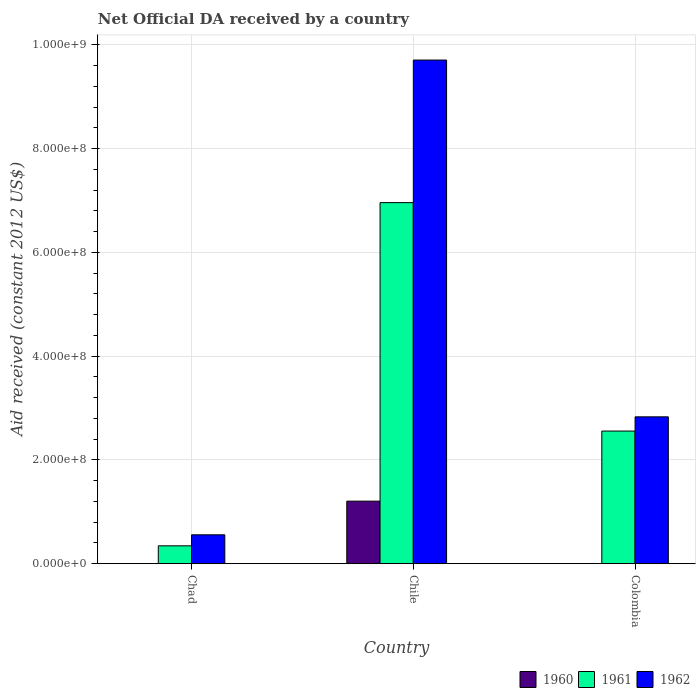How many different coloured bars are there?
Ensure brevity in your answer.  3. How many groups of bars are there?
Offer a terse response. 3. How many bars are there on the 3rd tick from the left?
Your answer should be compact. 2. Across all countries, what is the maximum net official development assistance aid received in 1962?
Make the answer very short. 9.71e+08. Across all countries, what is the minimum net official development assistance aid received in 1961?
Provide a succinct answer. 3.45e+07. In which country was the net official development assistance aid received in 1960 maximum?
Offer a very short reply. Chile. What is the total net official development assistance aid received in 1961 in the graph?
Your answer should be compact. 9.86e+08. What is the difference between the net official development assistance aid received in 1960 in Chad and that in Chile?
Offer a terse response. -1.20e+08. What is the difference between the net official development assistance aid received in 1962 in Chile and the net official development assistance aid received in 1960 in Colombia?
Offer a very short reply. 9.71e+08. What is the average net official development assistance aid received in 1961 per country?
Make the answer very short. 3.29e+08. What is the difference between the net official development assistance aid received of/in 1961 and net official development assistance aid received of/in 1962 in Chile?
Offer a very short reply. -2.75e+08. In how many countries, is the net official development assistance aid received in 1962 greater than 440000000 US$?
Make the answer very short. 1. What is the ratio of the net official development assistance aid received in 1962 in Chile to that in Colombia?
Provide a succinct answer. 3.43. Is the net official development assistance aid received in 1962 in Chad less than that in Chile?
Give a very brief answer. Yes. What is the difference between the highest and the second highest net official development assistance aid received in 1961?
Offer a terse response. 4.40e+08. What is the difference between the highest and the lowest net official development assistance aid received in 1961?
Your response must be concise. 6.61e+08. How many countries are there in the graph?
Offer a terse response. 3. What is the difference between two consecutive major ticks on the Y-axis?
Ensure brevity in your answer.  2.00e+08. Does the graph contain any zero values?
Your answer should be compact. Yes. Where does the legend appear in the graph?
Your response must be concise. Bottom right. How many legend labels are there?
Your answer should be compact. 3. How are the legend labels stacked?
Your answer should be compact. Horizontal. What is the title of the graph?
Offer a very short reply. Net Official DA received by a country. What is the label or title of the X-axis?
Your answer should be very brief. Country. What is the label or title of the Y-axis?
Offer a very short reply. Aid received (constant 2012 US$). What is the Aid received (constant 2012 US$) of 1960 in Chad?
Keep it short and to the point. 3.00e+05. What is the Aid received (constant 2012 US$) of 1961 in Chad?
Your answer should be compact. 3.45e+07. What is the Aid received (constant 2012 US$) in 1962 in Chad?
Give a very brief answer. 5.57e+07. What is the Aid received (constant 2012 US$) in 1960 in Chile?
Keep it short and to the point. 1.21e+08. What is the Aid received (constant 2012 US$) in 1961 in Chile?
Make the answer very short. 6.96e+08. What is the Aid received (constant 2012 US$) in 1962 in Chile?
Make the answer very short. 9.71e+08. What is the Aid received (constant 2012 US$) in 1960 in Colombia?
Your response must be concise. 0. What is the Aid received (constant 2012 US$) of 1961 in Colombia?
Provide a succinct answer. 2.56e+08. What is the Aid received (constant 2012 US$) of 1962 in Colombia?
Your response must be concise. 2.83e+08. Across all countries, what is the maximum Aid received (constant 2012 US$) of 1960?
Provide a short and direct response. 1.21e+08. Across all countries, what is the maximum Aid received (constant 2012 US$) in 1961?
Your answer should be compact. 6.96e+08. Across all countries, what is the maximum Aid received (constant 2012 US$) of 1962?
Ensure brevity in your answer.  9.71e+08. Across all countries, what is the minimum Aid received (constant 2012 US$) in 1960?
Offer a terse response. 0. Across all countries, what is the minimum Aid received (constant 2012 US$) in 1961?
Your answer should be compact. 3.45e+07. Across all countries, what is the minimum Aid received (constant 2012 US$) in 1962?
Make the answer very short. 5.57e+07. What is the total Aid received (constant 2012 US$) of 1960 in the graph?
Give a very brief answer. 1.21e+08. What is the total Aid received (constant 2012 US$) of 1961 in the graph?
Make the answer very short. 9.86e+08. What is the total Aid received (constant 2012 US$) of 1962 in the graph?
Your answer should be compact. 1.31e+09. What is the difference between the Aid received (constant 2012 US$) of 1960 in Chad and that in Chile?
Provide a succinct answer. -1.20e+08. What is the difference between the Aid received (constant 2012 US$) in 1961 in Chad and that in Chile?
Make the answer very short. -6.61e+08. What is the difference between the Aid received (constant 2012 US$) in 1962 in Chad and that in Chile?
Give a very brief answer. -9.15e+08. What is the difference between the Aid received (constant 2012 US$) of 1961 in Chad and that in Colombia?
Ensure brevity in your answer.  -2.21e+08. What is the difference between the Aid received (constant 2012 US$) in 1962 in Chad and that in Colombia?
Your response must be concise. -2.27e+08. What is the difference between the Aid received (constant 2012 US$) of 1961 in Chile and that in Colombia?
Your response must be concise. 4.40e+08. What is the difference between the Aid received (constant 2012 US$) of 1962 in Chile and that in Colombia?
Provide a succinct answer. 6.88e+08. What is the difference between the Aid received (constant 2012 US$) in 1960 in Chad and the Aid received (constant 2012 US$) in 1961 in Chile?
Provide a succinct answer. -6.96e+08. What is the difference between the Aid received (constant 2012 US$) in 1960 in Chad and the Aid received (constant 2012 US$) in 1962 in Chile?
Give a very brief answer. -9.70e+08. What is the difference between the Aid received (constant 2012 US$) in 1961 in Chad and the Aid received (constant 2012 US$) in 1962 in Chile?
Offer a very short reply. -9.36e+08. What is the difference between the Aid received (constant 2012 US$) of 1960 in Chad and the Aid received (constant 2012 US$) of 1961 in Colombia?
Ensure brevity in your answer.  -2.55e+08. What is the difference between the Aid received (constant 2012 US$) in 1960 in Chad and the Aid received (constant 2012 US$) in 1962 in Colombia?
Your answer should be very brief. -2.83e+08. What is the difference between the Aid received (constant 2012 US$) in 1961 in Chad and the Aid received (constant 2012 US$) in 1962 in Colombia?
Your answer should be compact. -2.49e+08. What is the difference between the Aid received (constant 2012 US$) in 1960 in Chile and the Aid received (constant 2012 US$) in 1961 in Colombia?
Your answer should be compact. -1.35e+08. What is the difference between the Aid received (constant 2012 US$) in 1960 in Chile and the Aid received (constant 2012 US$) in 1962 in Colombia?
Ensure brevity in your answer.  -1.63e+08. What is the difference between the Aid received (constant 2012 US$) in 1961 in Chile and the Aid received (constant 2012 US$) in 1962 in Colombia?
Provide a short and direct response. 4.13e+08. What is the average Aid received (constant 2012 US$) of 1960 per country?
Make the answer very short. 4.03e+07. What is the average Aid received (constant 2012 US$) of 1961 per country?
Offer a very short reply. 3.29e+08. What is the average Aid received (constant 2012 US$) in 1962 per country?
Offer a very short reply. 4.37e+08. What is the difference between the Aid received (constant 2012 US$) of 1960 and Aid received (constant 2012 US$) of 1961 in Chad?
Offer a terse response. -3.42e+07. What is the difference between the Aid received (constant 2012 US$) in 1960 and Aid received (constant 2012 US$) in 1962 in Chad?
Give a very brief answer. -5.54e+07. What is the difference between the Aid received (constant 2012 US$) in 1961 and Aid received (constant 2012 US$) in 1962 in Chad?
Make the answer very short. -2.12e+07. What is the difference between the Aid received (constant 2012 US$) of 1960 and Aid received (constant 2012 US$) of 1961 in Chile?
Give a very brief answer. -5.75e+08. What is the difference between the Aid received (constant 2012 US$) in 1960 and Aid received (constant 2012 US$) in 1962 in Chile?
Your response must be concise. -8.50e+08. What is the difference between the Aid received (constant 2012 US$) in 1961 and Aid received (constant 2012 US$) in 1962 in Chile?
Your answer should be very brief. -2.75e+08. What is the difference between the Aid received (constant 2012 US$) in 1961 and Aid received (constant 2012 US$) in 1962 in Colombia?
Provide a succinct answer. -2.74e+07. What is the ratio of the Aid received (constant 2012 US$) of 1960 in Chad to that in Chile?
Make the answer very short. 0. What is the ratio of the Aid received (constant 2012 US$) of 1961 in Chad to that in Chile?
Provide a succinct answer. 0.05. What is the ratio of the Aid received (constant 2012 US$) in 1962 in Chad to that in Chile?
Provide a short and direct response. 0.06. What is the ratio of the Aid received (constant 2012 US$) of 1961 in Chad to that in Colombia?
Offer a very short reply. 0.14. What is the ratio of the Aid received (constant 2012 US$) of 1962 in Chad to that in Colombia?
Make the answer very short. 0.2. What is the ratio of the Aid received (constant 2012 US$) of 1961 in Chile to that in Colombia?
Give a very brief answer. 2.72. What is the ratio of the Aid received (constant 2012 US$) in 1962 in Chile to that in Colombia?
Your answer should be very brief. 3.43. What is the difference between the highest and the second highest Aid received (constant 2012 US$) of 1961?
Provide a succinct answer. 4.40e+08. What is the difference between the highest and the second highest Aid received (constant 2012 US$) of 1962?
Keep it short and to the point. 6.88e+08. What is the difference between the highest and the lowest Aid received (constant 2012 US$) of 1960?
Offer a very short reply. 1.21e+08. What is the difference between the highest and the lowest Aid received (constant 2012 US$) in 1961?
Provide a short and direct response. 6.61e+08. What is the difference between the highest and the lowest Aid received (constant 2012 US$) of 1962?
Provide a short and direct response. 9.15e+08. 